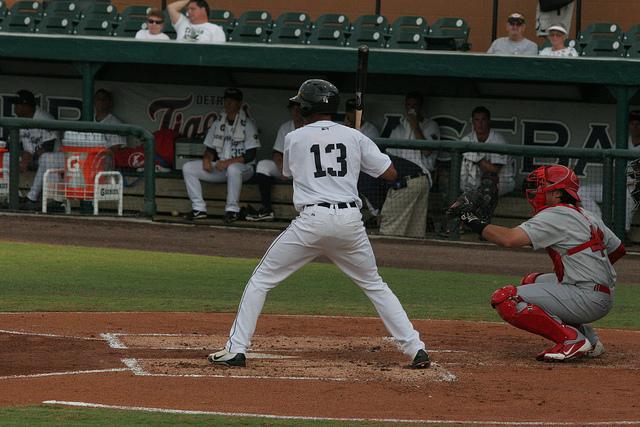What number is the batter?
Concise answer only. 13. What number is on the uniform of the person at bat?
Quick response, please. 13. Who is behind the catcher?
Short answer required. Umpire. How many players are seen?
Write a very short answer. 8. What is the man doing holding the bat?
Give a very brief answer. Batting. Are many people watching the match?
Keep it brief. 4. What is the color of the batter's helmet?
Concise answer only. Black. Is the stadium full?
Answer briefly. No. What is the Jersey number of the battery?
Answer briefly. 13. Is there a Gatorade container?
Keep it brief. Yes. What number can be seen on the batter's Jersey?
Write a very short answer. 13. Is the boy who is batting on the same team as the players in the dugout?
Write a very short answer. Yes. What is the batter's jersey number?
Give a very brief answer. 13. What number is on the batters uniform?
Answer briefly. 13. What is the number on the player's jersey?
Quick response, please. 13. What is this player's number?
Keep it brief. 13. What color is his uniform at bat?
Keep it brief. White. What is the man with the bat doing?
Be succinct. Batting. What material is the bat?
Give a very brief answer. Wood. Is the batter standing over the plate?
Be succinct. Yes. What pattern is the batters Jersey?
Be succinct. Solid. Is the batter swinging with his right or left hand?
Short answer required. Right. Is the man swinging the bat?
Write a very short answer. No. What number is on the batters jersey?
Concise answer only. 13. 